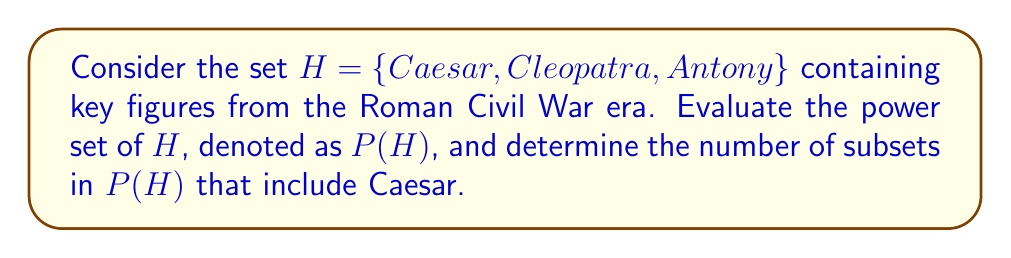Help me with this question. To solve this problem, let's follow these steps:

1) First, recall that the power set of a set $S$ is the set of all possible subsets of $S$, including the empty set and $S$ itself.

2) For a set with $n$ elements, the power set will have $2^n$ elements.

3) In this case, $|H| = 3$, so $|P(H)| = 2^3 = 8$.

4) Let's list all the elements of $P(H)$:

   $P(H) = \{\emptyset, \{Caesar\}, \{Cleopatra\}, \{Antony\}, \{Caesar, Cleopatra\}, \{Caesar, Antony\}, \{Cleopatra, Antony\}, \{Caesar, Cleopatra, Antony\}\}$

5) To determine how many subsets in $P(H)$ include Caesar, we need to count the subsets that contain Caesar:

   $\{Caesar\}$
   $\{Caesar, Cleopatra\}$
   $\{Caesar, Antony\}$
   $\{Caesar, Cleopatra, Antony\}$

6) We can see that there are 4 such subsets.

7) Alternatively, we can calculate this using the following logic:
   - For every subset that includes Caesar, there is a corresponding subset that doesn't include Caesar.
   - Therefore, the number of subsets including Caesar is half of the total number of subsets in $P(H)$.
   - Mathematically, this is $\frac{|P(H)|}{2} = \frac{8}{2} = 4$.
Answer: The power set of $H$ is $P(H) = \{\emptyset, \{Caesar\}, \{Cleopatra\}, \{Antony\}, \{Caesar, Cleopatra\}, \{Caesar, Antony\}, \{Cleopatra, Antony\}, \{Caesar, Cleopatra, Antony\}\}$, and there are 4 subsets in $P(H)$ that include Caesar. 